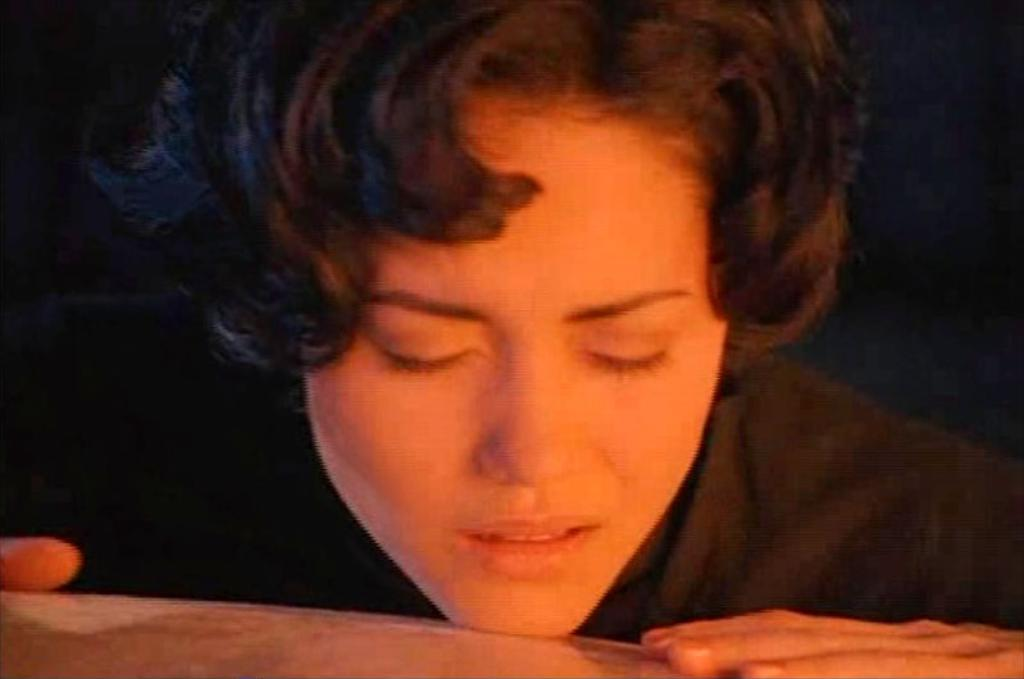What is present in the image? There is a person in the image. What is the person doing with their face and hands? The person has placed their face and hands on an object. What type of kettle is the person using to make oatmeal in the image? There is no kettle or oatmeal present in the image. The person is simply placing their face and hands on an object. 